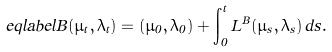Convert formula to latex. <formula><loc_0><loc_0><loc_500><loc_500>\ e q l a b e l { B } ( \mu _ { t } , \lambda _ { t } ) = ( \mu _ { 0 } , \lambda _ { 0 } ) + \int ^ { t } _ { 0 } L ^ { B } ( \mu _ { s } , \lambda _ { s } ) \, d s .</formula> 